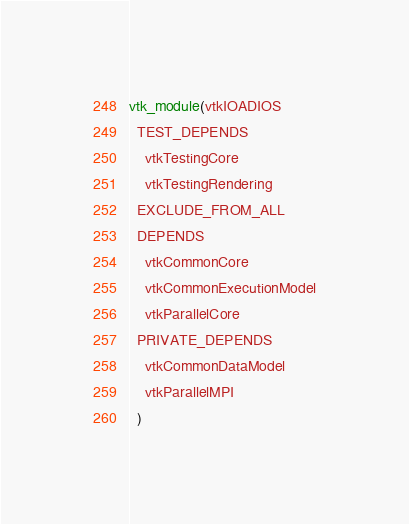<code> <loc_0><loc_0><loc_500><loc_500><_CMake_>vtk_module(vtkIOADIOS
  TEST_DEPENDS
    vtkTestingCore
    vtkTestingRendering
  EXCLUDE_FROM_ALL
  DEPENDS
    vtkCommonCore
    vtkCommonExecutionModel
    vtkParallelCore
  PRIVATE_DEPENDS
    vtkCommonDataModel
    vtkParallelMPI
  )</code> 